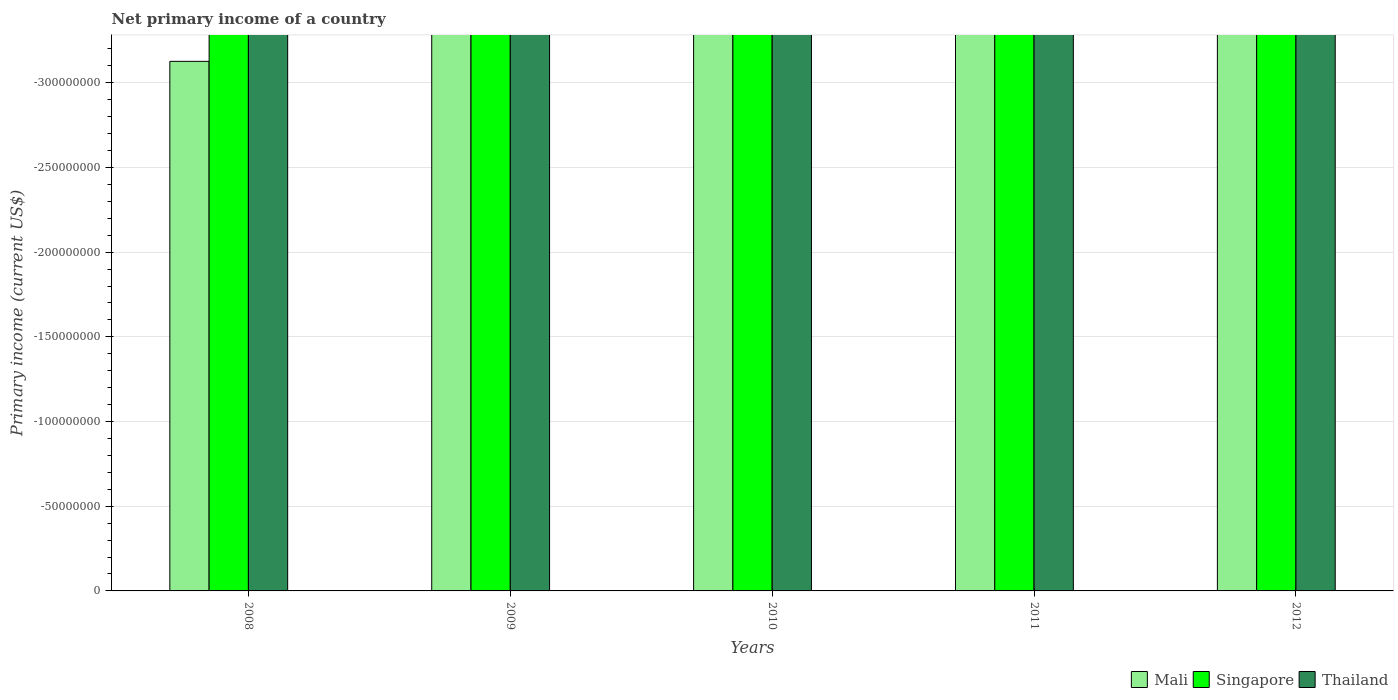How many different coloured bars are there?
Provide a succinct answer. 0. Are the number of bars per tick equal to the number of legend labels?
Make the answer very short. No. What is the primary income in Thailand in 2009?
Ensure brevity in your answer.  0. Across all years, what is the minimum primary income in Singapore?
Ensure brevity in your answer.  0. What is the total primary income in Singapore in the graph?
Your response must be concise. 0. In how many years, is the primary income in Mali greater than the average primary income in Mali taken over all years?
Your answer should be compact. 0. How many bars are there?
Your answer should be compact. 0. Are all the bars in the graph horizontal?
Keep it short and to the point. No. How many years are there in the graph?
Make the answer very short. 5. Does the graph contain any zero values?
Give a very brief answer. Yes. Where does the legend appear in the graph?
Keep it short and to the point. Bottom right. What is the title of the graph?
Make the answer very short. Net primary income of a country. What is the label or title of the X-axis?
Your answer should be very brief. Years. What is the label or title of the Y-axis?
Your response must be concise. Primary income (current US$). What is the Primary income (current US$) in Singapore in 2008?
Your answer should be very brief. 0. What is the Primary income (current US$) of Thailand in 2008?
Your answer should be compact. 0. What is the Primary income (current US$) in Mali in 2009?
Keep it short and to the point. 0. What is the Primary income (current US$) of Singapore in 2009?
Your answer should be compact. 0. What is the Primary income (current US$) in Thailand in 2010?
Give a very brief answer. 0. What is the Primary income (current US$) of Mali in 2011?
Ensure brevity in your answer.  0. What is the Primary income (current US$) of Mali in 2012?
Provide a short and direct response. 0. What is the Primary income (current US$) of Thailand in 2012?
Provide a short and direct response. 0. What is the total Primary income (current US$) of Singapore in the graph?
Keep it short and to the point. 0. What is the average Primary income (current US$) of Mali per year?
Your response must be concise. 0. What is the average Primary income (current US$) in Singapore per year?
Provide a succinct answer. 0. 